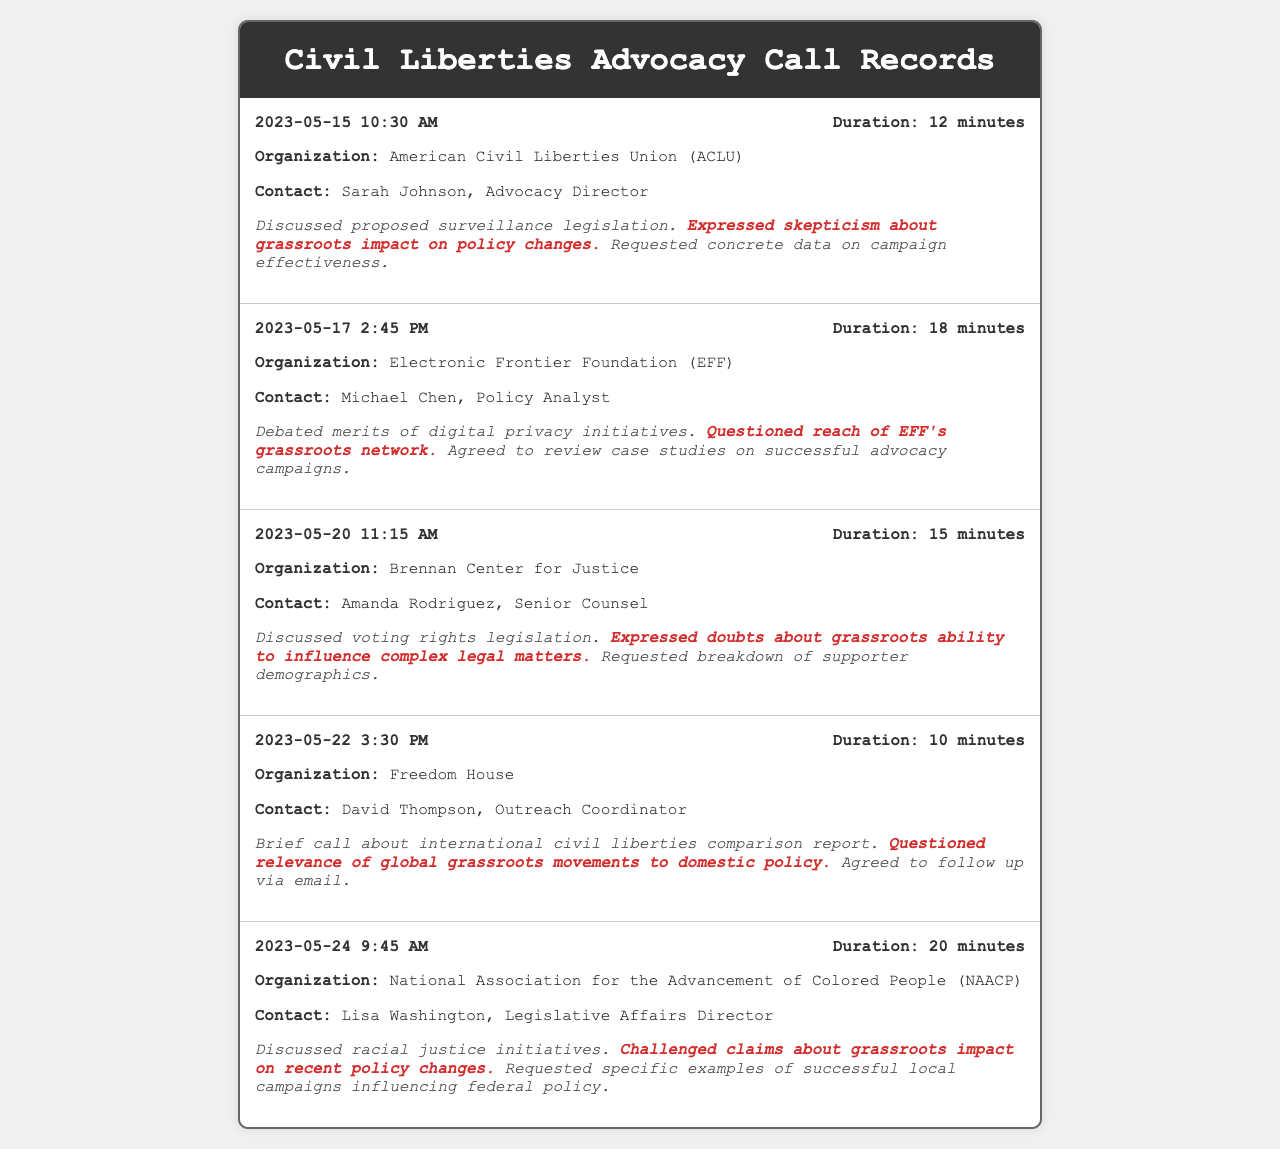What is the date of the call with the ACLU? The date of the call is specified in the call record for the ACLU, which is May 15, 2023.
Answer: May 15, 2023 Who is the contact person for the Electronic Frontier Foundation? The contact person for the EFF is listed in the call record, which is Michael Chen.
Answer: Michael Chen What was the duration of the call with Freedom House? The duration of the call is indicated in the record for Freedom House, which is 10 minutes.
Answer: 10 minutes What organization did Lisa Washington represent? The organization represented by Lisa Washington is specified in the call record, which is the NAACP.
Answer: NAACP What skepticism did Amanda Rodriguez express about grassroots efforts? The skepticism expressed by Amanda Rodriguez can be found in the call summary regarding grassroots influence on complex legal matters.
Answer: Ability to influence complex legal matters What was discussed in the call with the Brennan Center for Justice? The discussion topic of the call with the Brennan Center is noted, which is voting rights legislation.
Answer: Voting rights legislation What type of document is this? The document presents records of phone interactions pertaining to advocacy efforts, specifically focusing on civil liberties.
Answer: Telephone records How many minutes was the call with the Electronic Frontier Foundation? The call duration is stated directly in the EFF call record, which is 18 minutes.
Answer: 18 minutes 